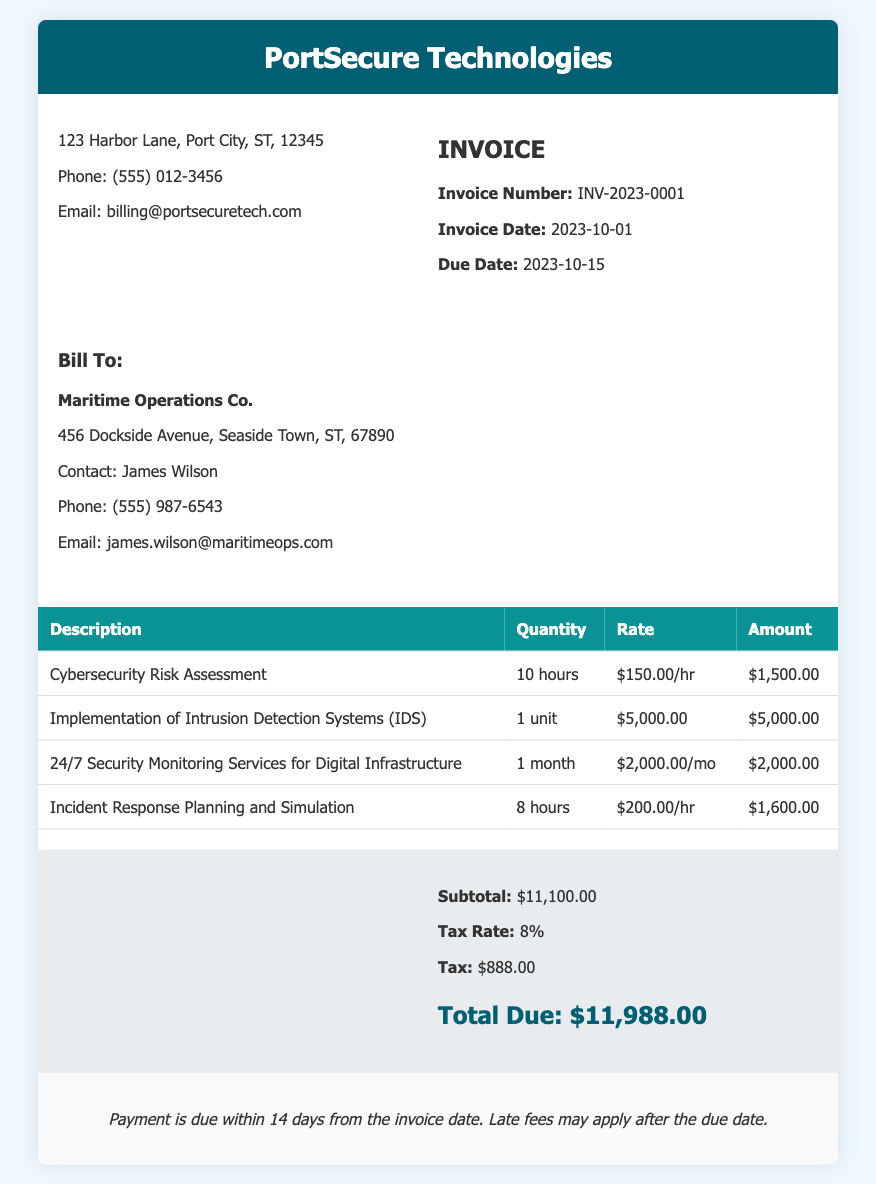What is the invoice number? The invoice number is a unique identifier assigned to this invoice, mentioned in the document.
Answer: INV-2023-0001 What is the due date for the invoice? The due date indicates when the payment should be completed, which is listed in the document.
Answer: 2023-10-15 Who is the contact person for the billing? The contact person is the individual responsible for communication related to the billing as provided in the document.
Answer: James Wilson What service has the highest cost? The highest cost service is identified in the invoice table, which summarizes the expenses for each service provided.
Answer: Implementation of Intrusion Detection Systems (IDS) What is the total amount due including tax? The total due includes all services and applicable taxes as calculated in the summary section of the document.
Answer: $11,988.00 How many hours were billed for the Cybersecurity Risk Assessment? The number of hours billed is specified in the table of services, detailing the time allocated for each service.
Answer: 10 hours What is the tax rate applied to the invoice? The tax rate is mentioned in the summary and is crucial for calculating the final amount due.
Answer: 8% How long is the 24/7 Security Monitoring Services contracted for? The duration for which the monitoring services are billed is specified in the services table.
Answer: 1 month What is stated about payment terms? The payment terms outline the required timing for payment and consequences of late payments as described in the document.
Answer: Payment is due within 14 days from the invoice date 